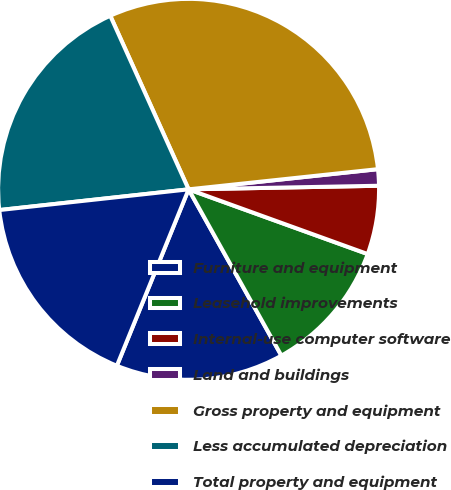<chart> <loc_0><loc_0><loc_500><loc_500><pie_chart><fcel>Furniture and equipment<fcel>Leasehold improvements<fcel>Internal-use computer software<fcel>Land and buildings<fcel>Gross property and equipment<fcel>Less accumulated depreciation<fcel>Total property and equipment<nl><fcel>14.25%<fcel>11.38%<fcel>5.82%<fcel>1.39%<fcel>30.06%<fcel>19.99%<fcel>17.12%<nl></chart> 